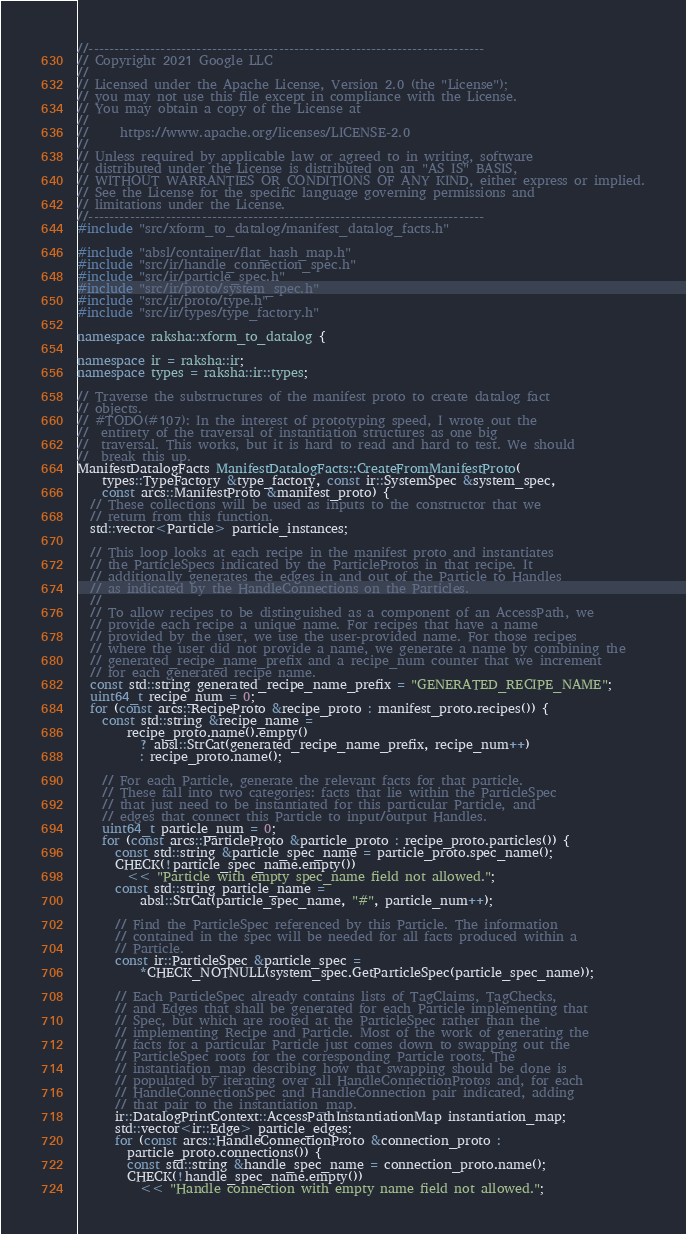<code> <loc_0><loc_0><loc_500><loc_500><_C++_>//-----------------------------------------------------------------------------
// Copyright 2021 Google LLC
//
// Licensed under the Apache License, Version 2.0 (the "License");
// you may not use this file except in compliance with the License.
// You may obtain a copy of the License at
//
//     https://www.apache.org/licenses/LICENSE-2.0
//
// Unless required by applicable law or agreed to in writing, software
// distributed under the License is distributed on an "AS IS" BASIS,
// WITHOUT WARRANTIES OR CONDITIONS OF ANY KIND, either express or implied.
// See the License for the specific language governing permissions and
// limitations under the License.
//-----------------------------------------------------------------------------
#include "src/xform_to_datalog/manifest_datalog_facts.h"

#include "absl/container/flat_hash_map.h"
#include "src/ir/handle_connection_spec.h"
#include "src/ir/particle_spec.h"
#include "src/ir/proto/system_spec.h"
#include "src/ir/proto/type.h"
#include "src/ir/types/type_factory.h"

namespace raksha::xform_to_datalog {

namespace ir = raksha::ir;
namespace types = raksha::ir::types;

// Traverse the substructures of the manifest proto to create datalog fact
// objects.
// #TODO(#107): In the interest of prototyping speed, I wrote out the
//  entirety of the traversal of instantiation structures as one big
//  traversal. This works, but it is hard to read and hard to test. We should
//  break this up.
ManifestDatalogFacts ManifestDatalogFacts::CreateFromManifestProto(
    types::TypeFactory &type_factory, const ir::SystemSpec &system_spec,
    const arcs::ManifestProto &manifest_proto) {
  // These collections will be used as inputs to the constructor that we
  // return from this function.
  std::vector<Particle> particle_instances;

  // This loop looks at each recipe in the manifest proto and instantiates
  // the ParticleSpecs indicated by the ParticleProtos in that recipe. It
  // additionally generates the edges in and out of the Particle to Handles
  // as indicated by the HandleConnections on the Particles.
  //
  // To allow recipes to be distinguished as a component of an AccessPath, we
  // provide each recipe a unique name. For recipes that have a name
  // provided by the user, we use the user-provided name. For those recipes
  // where the user did not provide a name, we generate a name by combining the
  // generated_recipe_name_prefix and a recipe_num counter that we increment
  // for each generated recipe name.
  const std::string generated_recipe_name_prefix = "GENERATED_RECIPE_NAME";
  uint64_t recipe_num = 0;
  for (const arcs::RecipeProto &recipe_proto : manifest_proto.recipes()) {
    const std::string &recipe_name =
        recipe_proto.name().empty()
          ? absl::StrCat(generated_recipe_name_prefix, recipe_num++)
          : recipe_proto.name();

    // For each Particle, generate the relevant facts for that particle.
    // These fall into two categories: facts that lie within the ParticleSpec
    // that just need to be instantiated for this particular Particle, and
    // edges that connect this Particle to input/output Handles.
    uint64_t particle_num = 0;
    for (const arcs::ParticleProto &particle_proto : recipe_proto.particles()) {
      const std::string &particle_spec_name = particle_proto.spec_name();
      CHECK(!particle_spec_name.empty())
        << "Particle with empty spec_name field not allowed.";
      const std::string particle_name =
          absl::StrCat(particle_spec_name, "#", particle_num++);

      // Find the ParticleSpec referenced by this Particle. The information
      // contained in the spec will be needed for all facts produced within a
      // Particle.
      const ir::ParticleSpec &particle_spec =
          *CHECK_NOTNULL(system_spec.GetParticleSpec(particle_spec_name));

      // Each ParticleSpec already contains lists of TagClaims, TagChecks,
      // and Edges that shall be generated for each Particle implementing that
      // Spec, but which are rooted at the ParticleSpec rather than the
      // implementing Recipe and Particle. Most of the work of generating the
      // facts for a particular Particle just comes down to swapping out the
      // ParticleSpec roots for the corresponding Particle roots. The
      // instantiation_map describing how that swapping should be done is
      // populated by iterating over all HandleConnectionProtos and, for each
      // HandleConnectionSpec and HandleConnection pair indicated, adding
      // that pair to the instantiation_map.
      ir::DatalogPrintContext::AccessPathInstantiationMap instantiation_map;
      std::vector<ir::Edge> particle_edges;
      for (const arcs::HandleConnectionProto &connection_proto :
        particle_proto.connections()) {
        const std::string &handle_spec_name = connection_proto.name();
        CHECK(!handle_spec_name.empty())
          << "Handle connection with empty name field not allowed.";</code> 